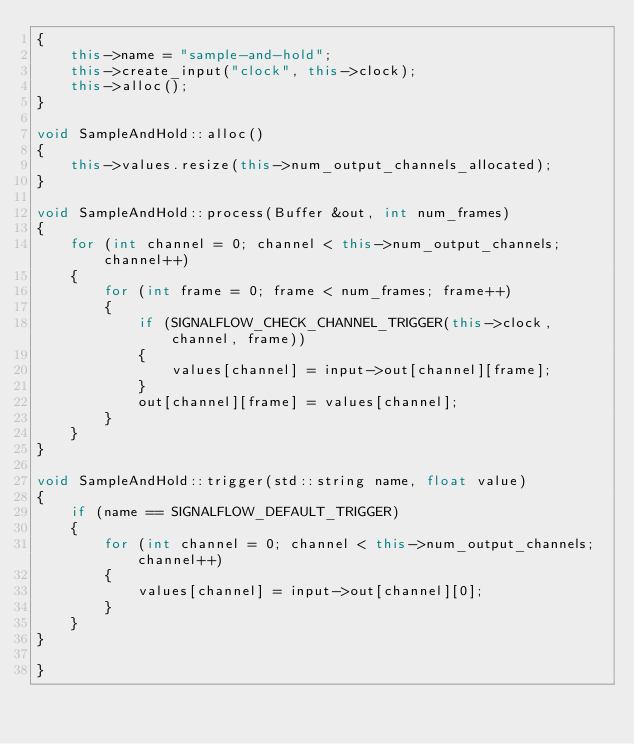<code> <loc_0><loc_0><loc_500><loc_500><_C++_>{
    this->name = "sample-and-hold";
    this->create_input("clock", this->clock);
    this->alloc();
}

void SampleAndHold::alloc()
{
    this->values.resize(this->num_output_channels_allocated);
}

void SampleAndHold::process(Buffer &out, int num_frames)
{
    for (int channel = 0; channel < this->num_output_channels; channel++)
    {
        for (int frame = 0; frame < num_frames; frame++)
        {
            if (SIGNALFLOW_CHECK_CHANNEL_TRIGGER(this->clock, channel, frame))
            {
                values[channel] = input->out[channel][frame];
            }
            out[channel][frame] = values[channel];
        }
    }
}

void SampleAndHold::trigger(std::string name, float value)
{
    if (name == SIGNALFLOW_DEFAULT_TRIGGER)
    {
        for (int channel = 0; channel < this->num_output_channels; channel++)
        {
            values[channel] = input->out[channel][0];
        }
    }
}

}
</code> 